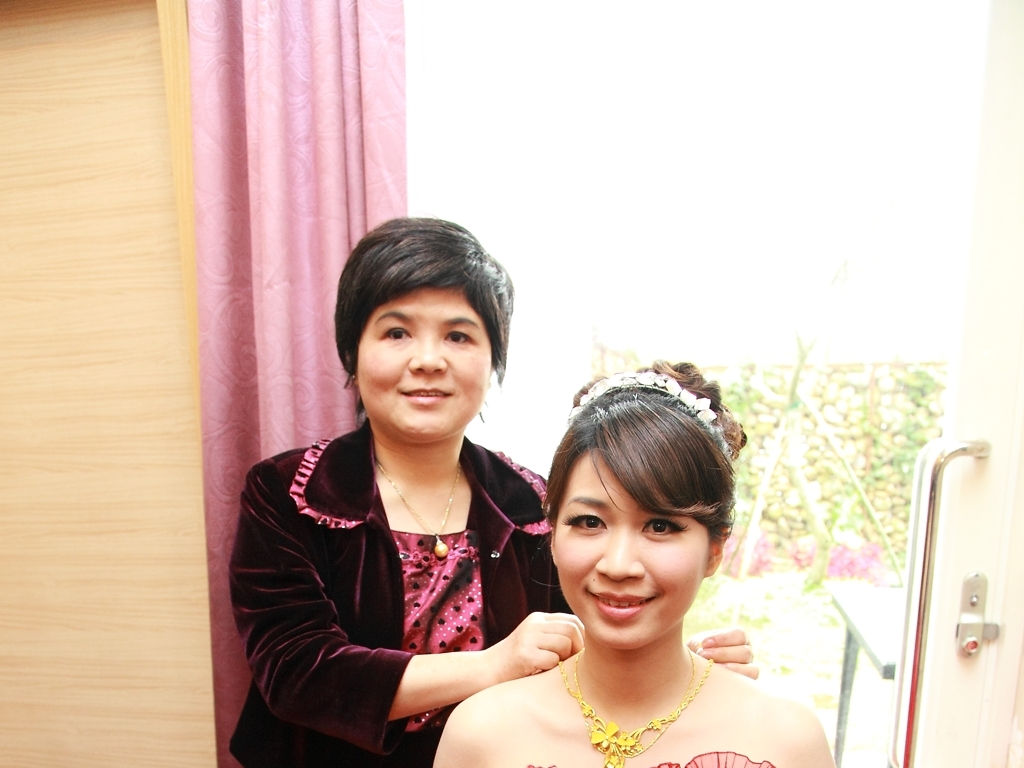What emotions are expressed by the individuals in the picture? The woman on the right, who is being helped with her outfit, shows a gentle smile, suggesting she is feeling content or happy. The woman on the left, who is assisting, has a neutral expression that could be interpreted as focused or attentive to the task at hand. 